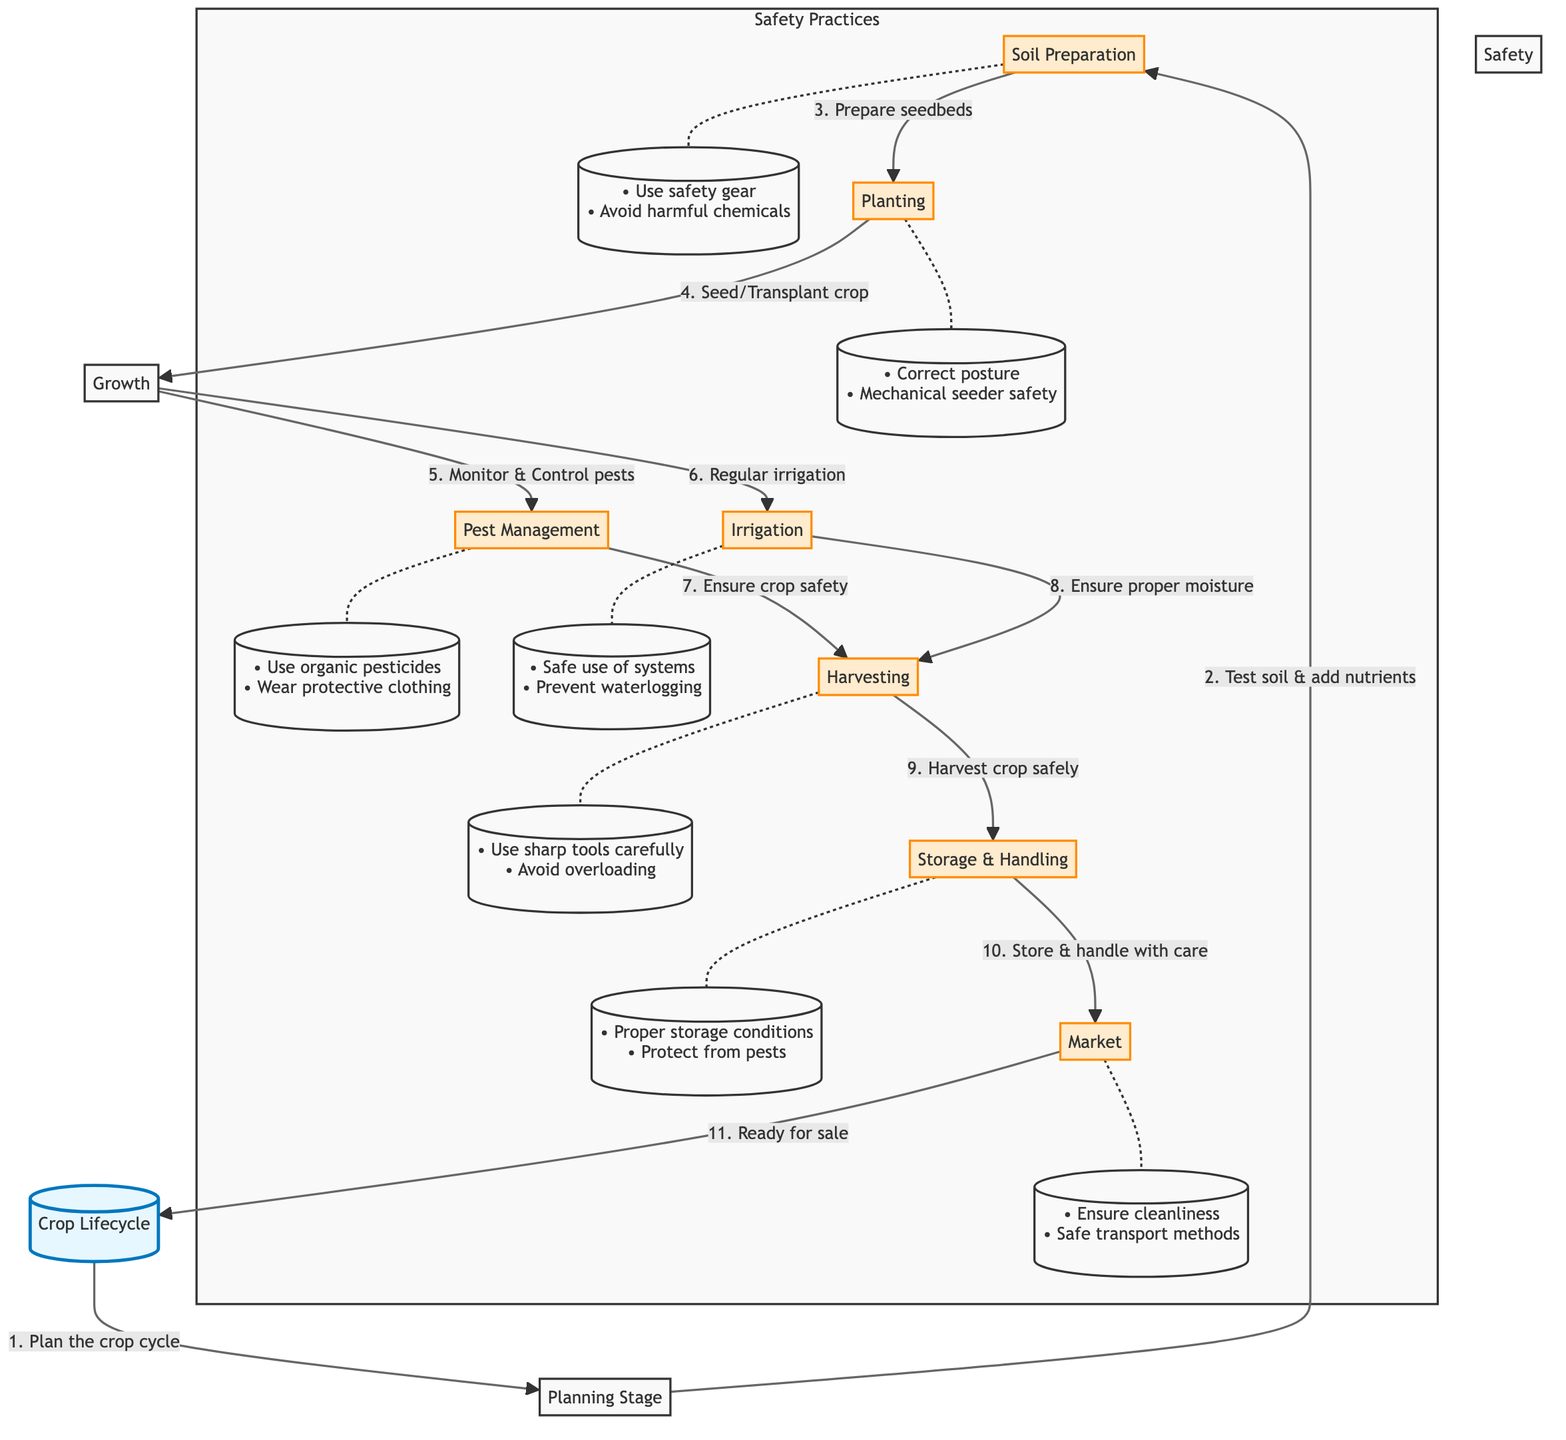What is the first step in the crop lifecycle? The first step in the crop lifecycle, as indicated in the diagram, is "Plan the crop cycle." This is the initial action that leads to the rest of the steps in the lifecycle.
Answer: Plan the crop cycle How many nodes are present in the safety practices subgraph? The subgraph labeled "Safety Practices" includes six nodes, each representing a different stage of crop lifecycle with associated safety practices.
Answer: 6 What is one safety practice listed for soil preparation? In the safety practices section, one of the safety practices listed for soil preparation is "Use safety gear." This emphasizes the importance of proper protective equipment during this stage.
Answer: Use safety gear Which stage follows pest management in the diagram? The diagram indicates that the stage that follows pest management is "Irrigation." This shows the sequential relationship between these necessary steps for crop growth.
Answer: Irrigation What safety practice is emphasized during the harvesting stage? The diagram notes two safety practices for harvesting: "Use sharp tools carefully" and "Avoid overloading." Both practices are critical in ensuring safety while performing this labor-intensive task.
Answer: Use sharp tools carefully How does the crop move from harvesting to storage and handling? The crop moves from harvesting to storage and handling through the directed arrow, indicating a clear flow from the harvesting task into the next phase of storing and careful handling before market.
Answer: Storage & Handling What is a recommended practice during pest management? A recommended practice during pest management is "Use organic pesticides." This highlights the preference for safer, sustainable options for managing pests in agriculture.
Answer: Use organic pesticides Which stage involves ensuring cleanliness before market? The stage that involves ensuring cleanliness before the market is "Market." This stage focuses on preparing the crops for sale in a clean and safe manner.
Answer: Market What is the final step in the crop lifecycle? The final step in the crop lifecycle is "Ready for sale." This indicates that after all the preparation and handling stages, the crop is now ready to be sold in the market.
Answer: Ready for sale 